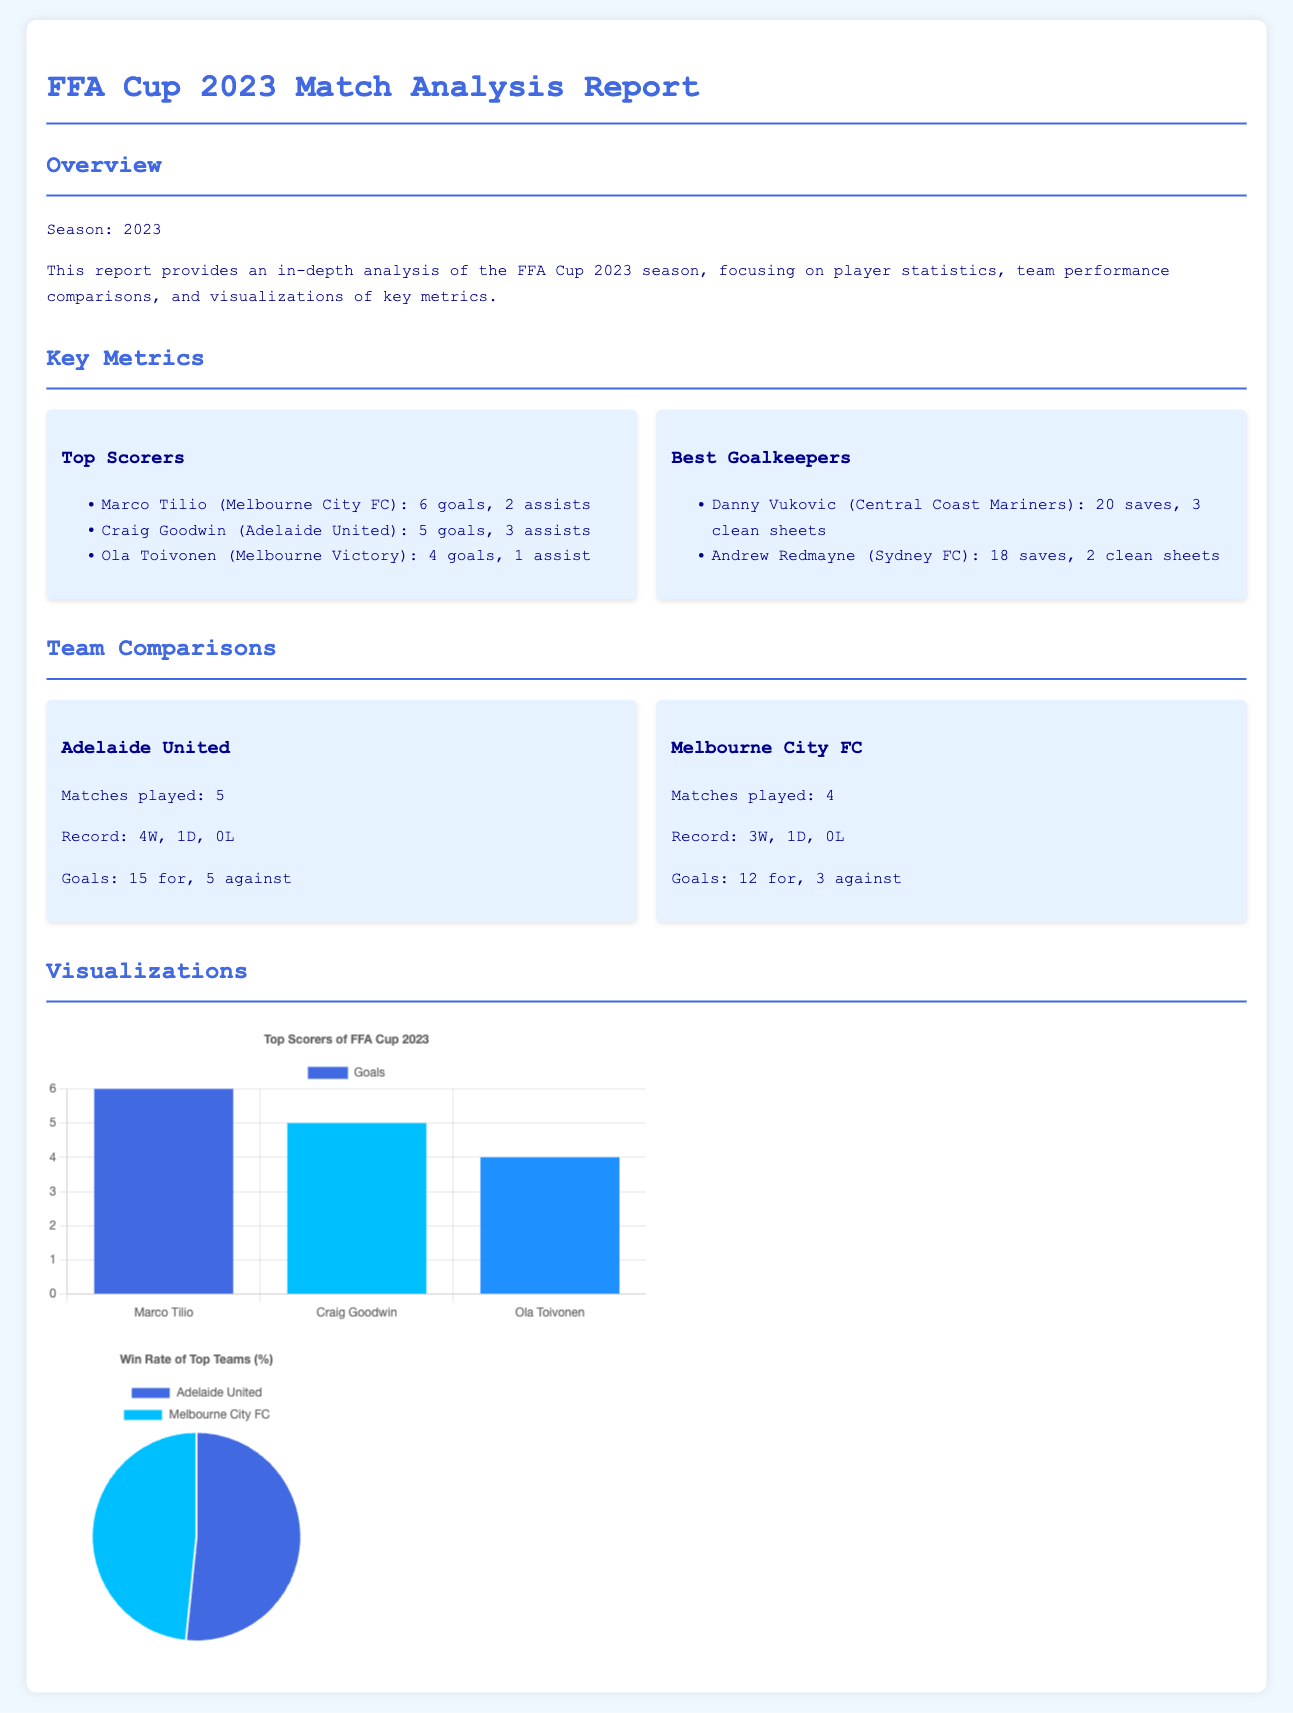What is the season of the FFA Cup reported? The document explicitly states that the season being reported is 2023.
Answer: 2023 Who is the top scorer of the FFA Cup 2023? The report lists Marco Tilio as the top scorer, with the most goals (6 goals).
Answer: Marco Tilio How many matches has Adelaide United played? The report mentions that Adelaide United has played 5 matches in total.
Answer: 5 What is the win rate percentage of Adelaide United? The document provides the win record for Adelaide United as 4 wins out of 5 matches, which translates to 80%.
Answer: 80 How many assists did Craig Goodwin have? Craig Goodwin is noted to have a total of 3 assists in the report.
Answer: 3 What is the number of clean sheets by Danny Vukovic? The report states that Danny Vukovic achieved 3 clean sheets.
Answer: 3 Which team has a total of 15 goals for? The report specifies that Adelaide United scored a total of 15 goals.
Answer: Adelaide United What data visualization is used to show the top scorers? The document indicates that a bar chart is used for the top scorers.
Answer: Bar chart What type of chart represents the win rate of the top teams? The document states that a pie chart is utilized to represent win rates.
Answer: Pie chart 